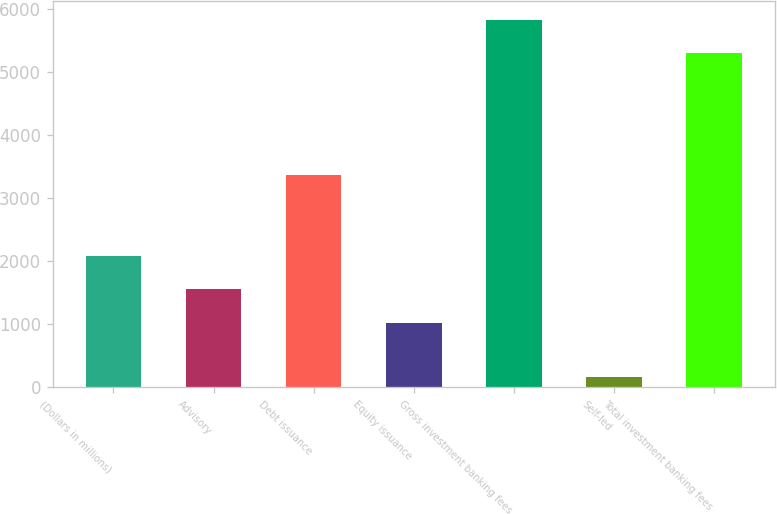Convert chart to OTSL. <chart><loc_0><loc_0><loc_500><loc_500><bar_chart><fcel>(Dollars in millions)<fcel>Advisory<fcel>Debt issuance<fcel>Equity issuance<fcel>Gross investment banking fees<fcel>Self-led<fcel>Total investment banking fees<nl><fcel>2085.8<fcel>1555.9<fcel>3362<fcel>1026<fcel>5828.9<fcel>155<fcel>5299<nl></chart> 